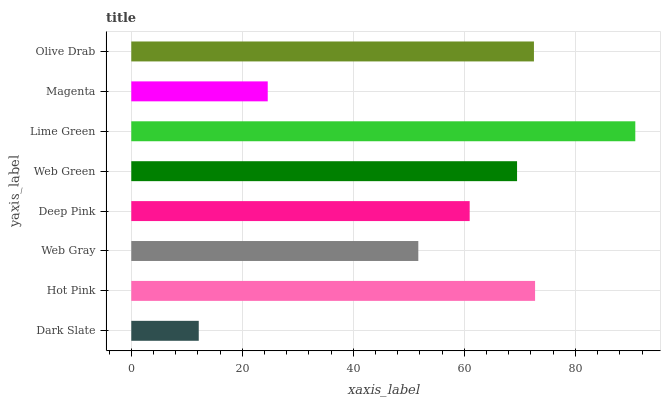Is Dark Slate the minimum?
Answer yes or no. Yes. Is Lime Green the maximum?
Answer yes or no. Yes. Is Hot Pink the minimum?
Answer yes or no. No. Is Hot Pink the maximum?
Answer yes or no. No. Is Hot Pink greater than Dark Slate?
Answer yes or no. Yes. Is Dark Slate less than Hot Pink?
Answer yes or no. Yes. Is Dark Slate greater than Hot Pink?
Answer yes or no. No. Is Hot Pink less than Dark Slate?
Answer yes or no. No. Is Web Green the high median?
Answer yes or no. Yes. Is Deep Pink the low median?
Answer yes or no. Yes. Is Deep Pink the high median?
Answer yes or no. No. Is Web Gray the low median?
Answer yes or no. No. 